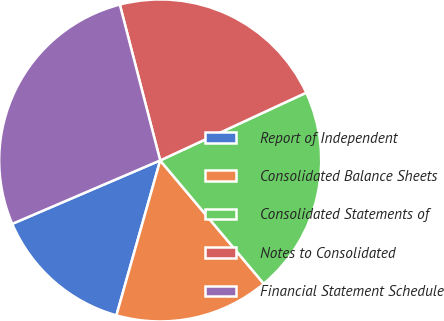<chart> <loc_0><loc_0><loc_500><loc_500><pie_chart><fcel>Report of Independent<fcel>Consolidated Balance Sheets<fcel>Consolidated Statements of<fcel>Notes to Consolidated<fcel>Financial Statement Schedule<nl><fcel>14.17%<fcel>15.5%<fcel>20.79%<fcel>22.12%<fcel>27.41%<nl></chart> 